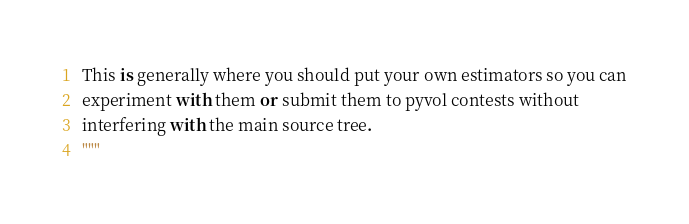Convert code to text. <code><loc_0><loc_0><loc_500><loc_500><_Python_>
This is generally where you should put your own estimators so you can
experiment with them or submit them to pyvol contests without
interfering with the main source tree.
"""
</code> 